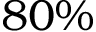Convert formula to latex. <formula><loc_0><loc_0><loc_500><loc_500>8 0 \%</formula> 